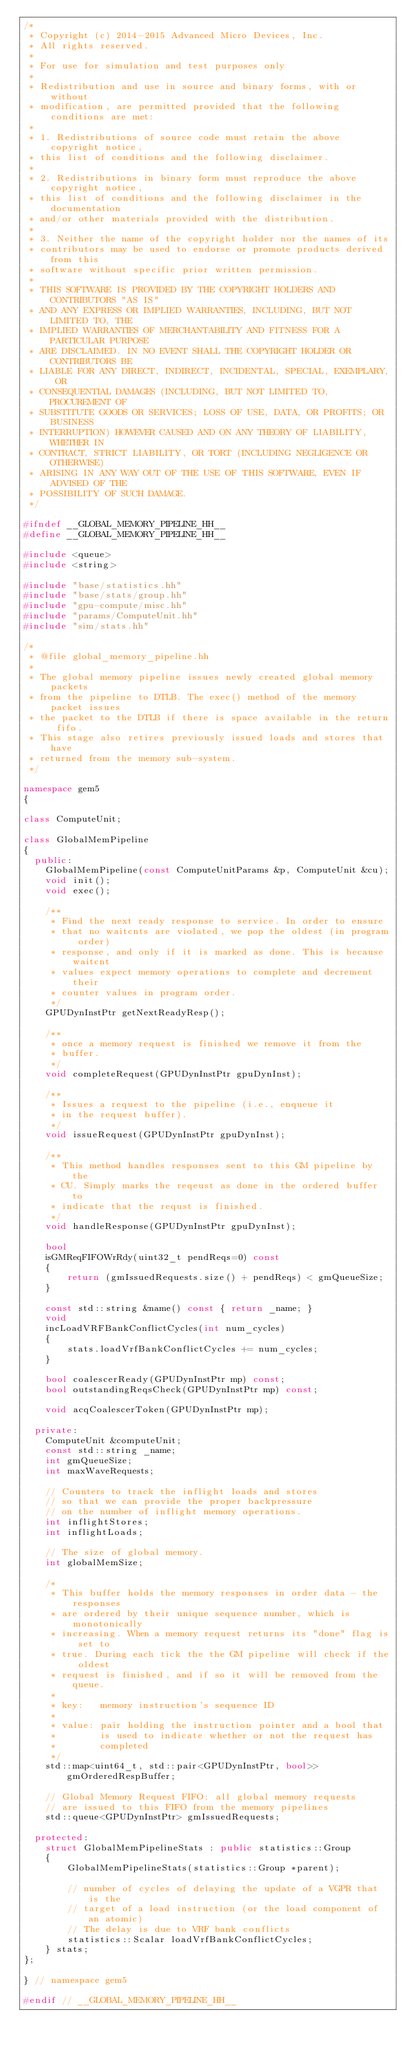<code> <loc_0><loc_0><loc_500><loc_500><_C++_>/*
 * Copyright (c) 2014-2015 Advanced Micro Devices, Inc.
 * All rights reserved.
 *
 * For use for simulation and test purposes only
 *
 * Redistribution and use in source and binary forms, with or without
 * modification, are permitted provided that the following conditions are met:
 *
 * 1. Redistributions of source code must retain the above copyright notice,
 * this list of conditions and the following disclaimer.
 *
 * 2. Redistributions in binary form must reproduce the above copyright notice,
 * this list of conditions and the following disclaimer in the documentation
 * and/or other materials provided with the distribution.
 *
 * 3. Neither the name of the copyright holder nor the names of its
 * contributors may be used to endorse or promote products derived from this
 * software without specific prior written permission.
 *
 * THIS SOFTWARE IS PROVIDED BY THE COPYRIGHT HOLDERS AND CONTRIBUTORS "AS IS"
 * AND ANY EXPRESS OR IMPLIED WARRANTIES, INCLUDING, BUT NOT LIMITED TO, THE
 * IMPLIED WARRANTIES OF MERCHANTABILITY AND FITNESS FOR A PARTICULAR PURPOSE
 * ARE DISCLAIMED. IN NO EVENT SHALL THE COPYRIGHT HOLDER OR CONTRIBUTORS BE
 * LIABLE FOR ANY DIRECT, INDIRECT, INCIDENTAL, SPECIAL, EXEMPLARY, OR
 * CONSEQUENTIAL DAMAGES (INCLUDING, BUT NOT LIMITED TO, PROCUREMENT OF
 * SUBSTITUTE GOODS OR SERVICES; LOSS OF USE, DATA, OR PROFITS; OR BUSINESS
 * INTERRUPTION) HOWEVER CAUSED AND ON ANY THEORY OF LIABILITY, WHETHER IN
 * CONTRACT, STRICT LIABILITY, OR TORT (INCLUDING NEGLIGENCE OR OTHERWISE)
 * ARISING IN ANY WAY OUT OF THE USE OF THIS SOFTWARE, EVEN IF ADVISED OF THE
 * POSSIBILITY OF SUCH DAMAGE.
 */

#ifndef __GLOBAL_MEMORY_PIPELINE_HH__
#define __GLOBAL_MEMORY_PIPELINE_HH__

#include <queue>
#include <string>

#include "base/statistics.hh"
#include "base/stats/group.hh"
#include "gpu-compute/misc.hh"
#include "params/ComputeUnit.hh"
#include "sim/stats.hh"

/*
 * @file global_memory_pipeline.hh
 *
 * The global memory pipeline issues newly created global memory packets
 * from the pipeline to DTLB. The exec() method of the memory packet issues
 * the packet to the DTLB if there is space available in the return fifo.
 * This stage also retires previously issued loads and stores that have
 * returned from the memory sub-system.
 */

namespace gem5
{

class ComputeUnit;

class GlobalMemPipeline
{
  public:
    GlobalMemPipeline(const ComputeUnitParams &p, ComputeUnit &cu);
    void init();
    void exec();

    /**
     * Find the next ready response to service. In order to ensure
     * that no waitcnts are violated, we pop the oldest (in program order)
     * response, and only if it is marked as done. This is because waitcnt
     * values expect memory operations to complete and decrement their
     * counter values in program order.
     */
    GPUDynInstPtr getNextReadyResp();

    /**
     * once a memory request is finished we remove it from the
     * buffer.
     */
    void completeRequest(GPUDynInstPtr gpuDynInst);

    /**
     * Issues a request to the pipeline (i.e., enqueue it
     * in the request buffer).
     */
    void issueRequest(GPUDynInstPtr gpuDynInst);

    /**
     * This method handles responses sent to this GM pipeline by the
     * CU. Simply marks the reqeust as done in the ordered buffer to
     * indicate that the requst is finished.
     */
    void handleResponse(GPUDynInstPtr gpuDynInst);

    bool
    isGMReqFIFOWrRdy(uint32_t pendReqs=0) const
    {
        return (gmIssuedRequests.size() + pendReqs) < gmQueueSize;
    }

    const std::string &name() const { return _name; }
    void
    incLoadVRFBankConflictCycles(int num_cycles)
    {
        stats.loadVrfBankConflictCycles += num_cycles;
    }

    bool coalescerReady(GPUDynInstPtr mp) const;
    bool outstandingReqsCheck(GPUDynInstPtr mp) const;

    void acqCoalescerToken(GPUDynInstPtr mp);

  private:
    ComputeUnit &computeUnit;
    const std::string _name;
    int gmQueueSize;
    int maxWaveRequests;

    // Counters to track the inflight loads and stores
    // so that we can provide the proper backpressure
    // on the number of inflight memory operations.
    int inflightStores;
    int inflightLoads;

    // The size of global memory.
    int globalMemSize;

    /*
     * This buffer holds the memory responses in order data - the responses
     * are ordered by their unique sequence number, which is monotonically
     * increasing. When a memory request returns its "done" flag is set to
     * true. During each tick the the GM pipeline will check if the oldest
     * request is finished, and if so it will be removed from the queue.
     *
     * key:   memory instruction's sequence ID
     *
     * value: pair holding the instruction pointer and a bool that
     *        is used to indicate whether or not the request has
     *        completed
     */
    std::map<uint64_t, std::pair<GPUDynInstPtr, bool>> gmOrderedRespBuffer;

    // Global Memory Request FIFO: all global memory requests
    // are issued to this FIFO from the memory pipelines
    std::queue<GPUDynInstPtr> gmIssuedRequests;

  protected:
    struct GlobalMemPipelineStats : public statistics::Group
    {
        GlobalMemPipelineStats(statistics::Group *parent);

        // number of cycles of delaying the update of a VGPR that is the
        // target of a load instruction (or the load component of an atomic)
        // The delay is due to VRF bank conflicts
        statistics::Scalar loadVrfBankConflictCycles;
    } stats;
};

} // namespace gem5

#endif // __GLOBAL_MEMORY_PIPELINE_HH__
</code> 